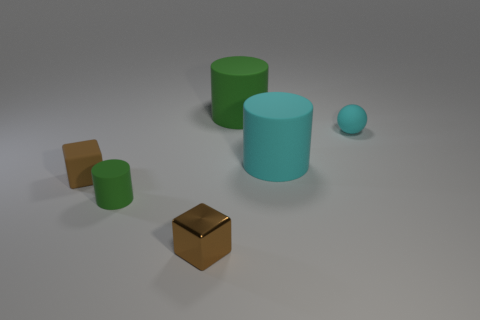There is a green object in front of the sphere; what is its size?
Your response must be concise. Small. How many other brown things are the same shape as the metal object?
Keep it short and to the point. 1. There is a big object that is the same color as the sphere; what is its material?
Your answer should be very brief. Rubber. What number of objects are big red shiny things or rubber objects on the left side of the brown shiny cube?
Keep it short and to the point. 2. There is another brown object that is the same shape as the metal object; what material is it?
Your answer should be very brief. Rubber. What color is the cube that is on the left side of the small block in front of the tiny brown matte cube?
Offer a terse response. Brown. What number of shiny objects are big cyan cylinders or large green objects?
Provide a succinct answer. 0. Are the big green object and the cyan ball made of the same material?
Provide a succinct answer. Yes. There is a cyan thing right of the large cylinder in front of the tiny cyan thing; what is it made of?
Offer a terse response. Rubber. What number of big objects are either red things or cubes?
Offer a very short reply. 0. 